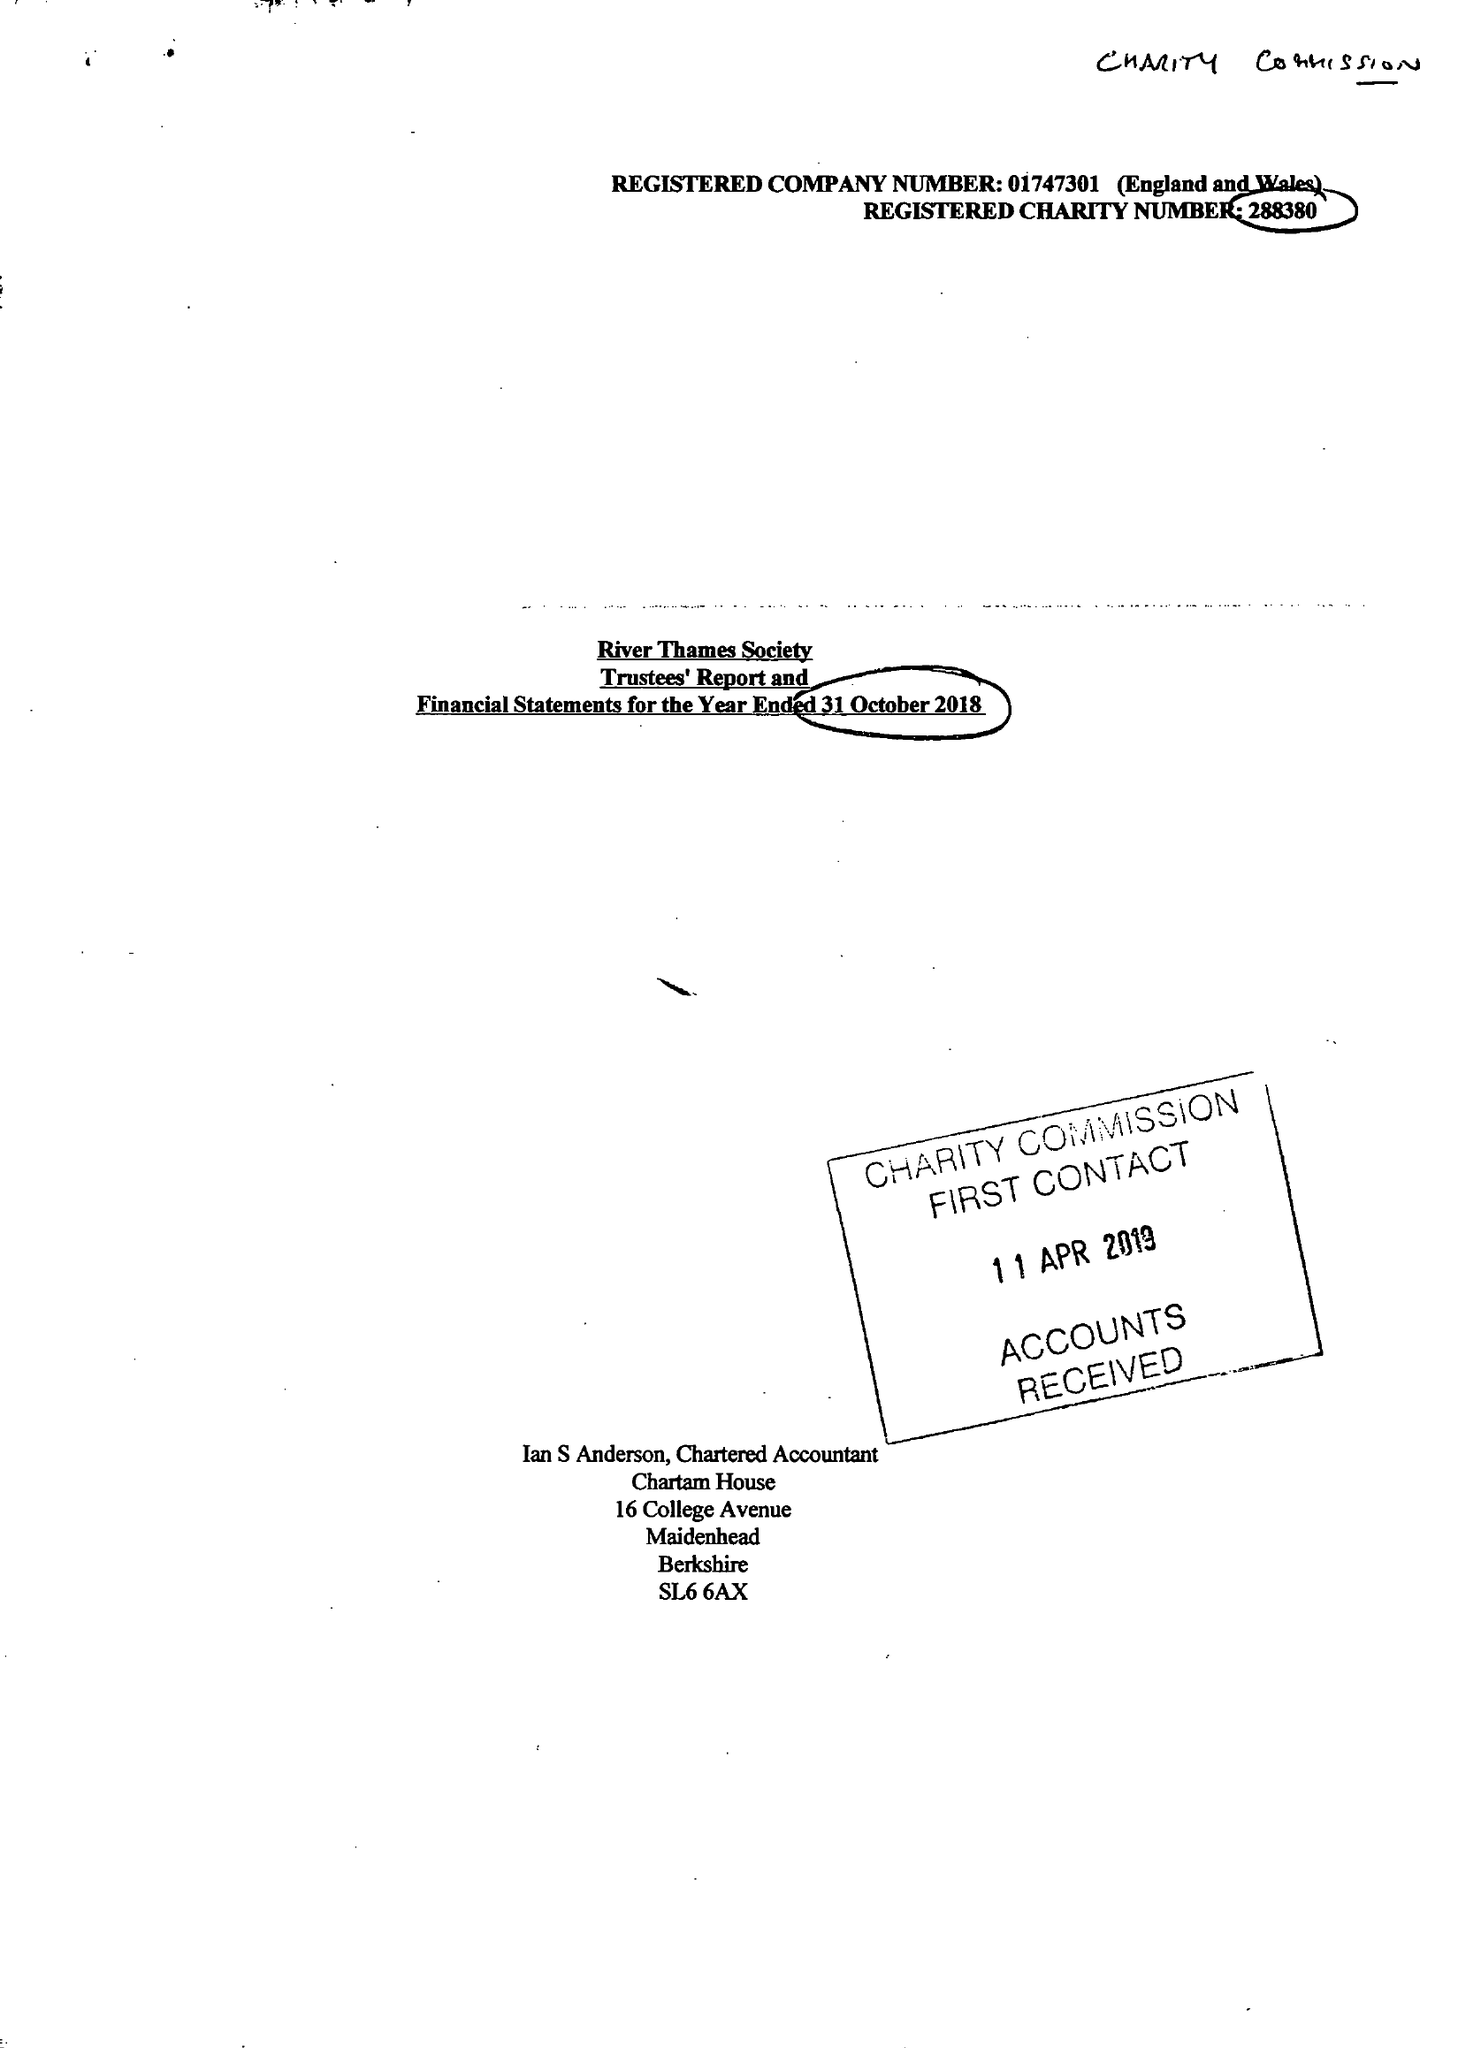What is the value for the report_date?
Answer the question using a single word or phrase. 2018-10-31 